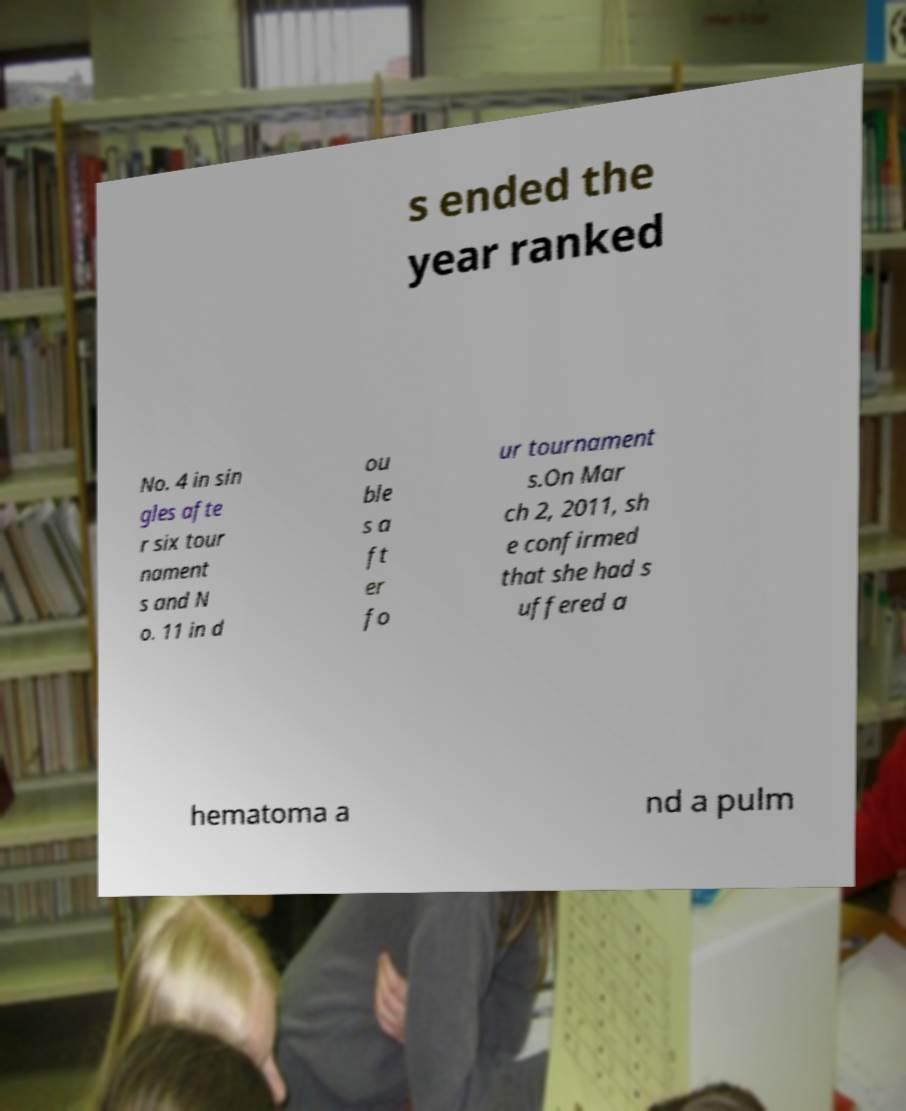Can you accurately transcribe the text from the provided image for me? s ended the year ranked No. 4 in sin gles afte r six tour nament s and N o. 11 in d ou ble s a ft er fo ur tournament s.On Mar ch 2, 2011, sh e confirmed that she had s uffered a hematoma a nd a pulm 